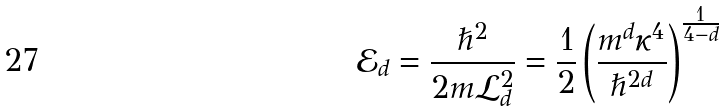Convert formula to latex. <formula><loc_0><loc_0><loc_500><loc_500>\mathcal { E } _ { d } = \frac { \hslash ^ { 2 } } { 2 m \mathcal { L } _ { d } ^ { 2 } } = \frac { 1 } { 2 } \left ( \frac { m ^ { d } \kappa ^ { 4 } } { \hslash ^ { 2 d } } \right ) ^ { \frac { 1 } { 4 - d } }</formula> 